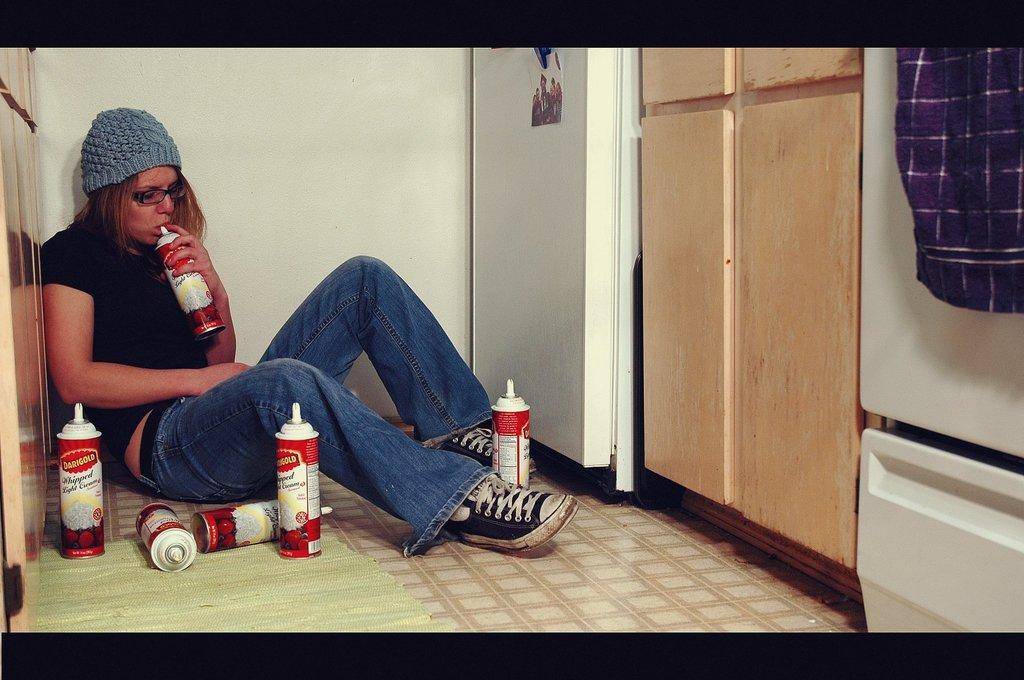What can be seen in the image that is used for holding liquids? There are bottles in the image that are used for holding liquids. What is displayed in the image that might be a memory or representation of a moment? There is a photo in the image that might be a memory or representation of a moment. What material is present in the image that can be used for various purposes, such as covering or cleaning? There is cloth in the image that can be used for various purposes, such as covering or cleaning. What type of structure is visible in the image that provides support and encloses space? There are walls in the image that provide support and enclose space. What is the woman in the image wearing on her head? The woman is wearing a cap in the image. What accessory is the woman wearing on her face in the image? The woman is wearing spectacles in the image. Where is the woman in the image sitting? The woman is sitting on the floor in the image. What other items can be seen in the image besides the ones mentioned? There are some objects in the image. What is the cent of the impulse in the image? There is no mention of a cent or impulse in the image; it contains bottles, a photo, cloth, walls, a woman wearing a cap and spectacles, and some objects. What is the power of the woman in the image? There is no mention of power in the image; it contains bottles, a photo, cloth, walls, a woman wearing a cap and some objects. 